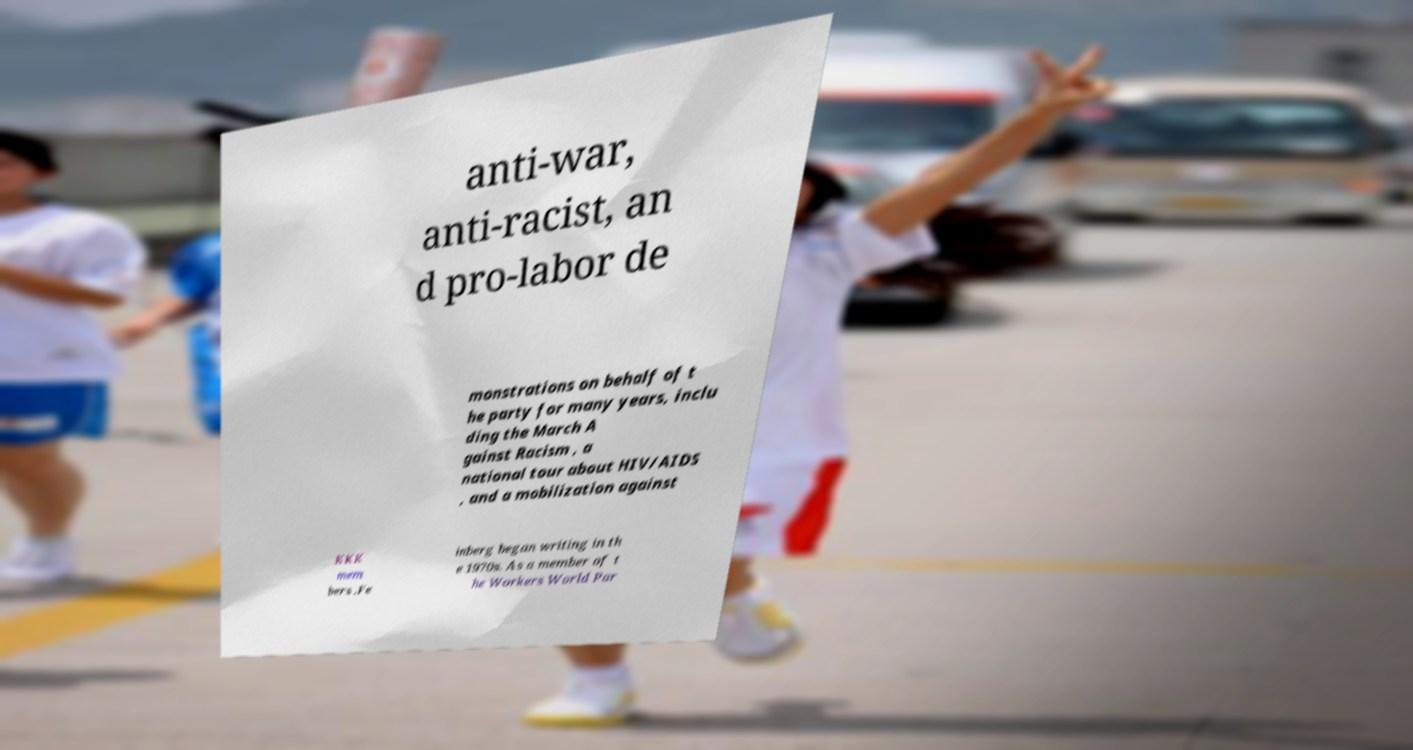I need the written content from this picture converted into text. Can you do that? anti-war, anti-racist, an d pro-labor de monstrations on behalf of t he party for many years, inclu ding the March A gainst Racism , a national tour about HIV/AIDS , and a mobilization against KKK mem bers .Fe inberg began writing in th e 1970s. As a member of t he Workers World Par 